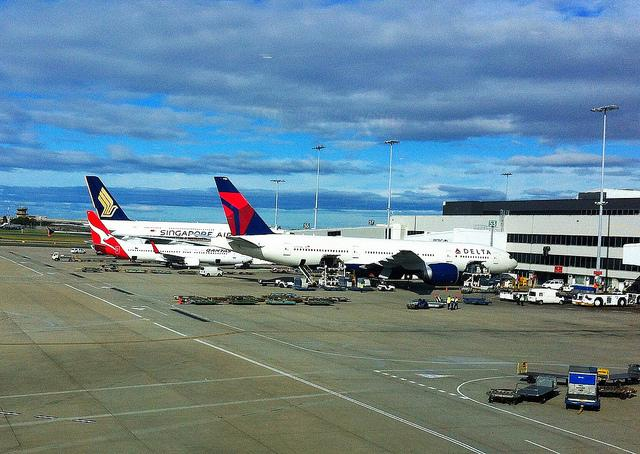How many different airlines are being featured by the planes in the photo? Please explain your reasoning. three. 3 different airlines, singapore, delta, and qantas can be seen. 